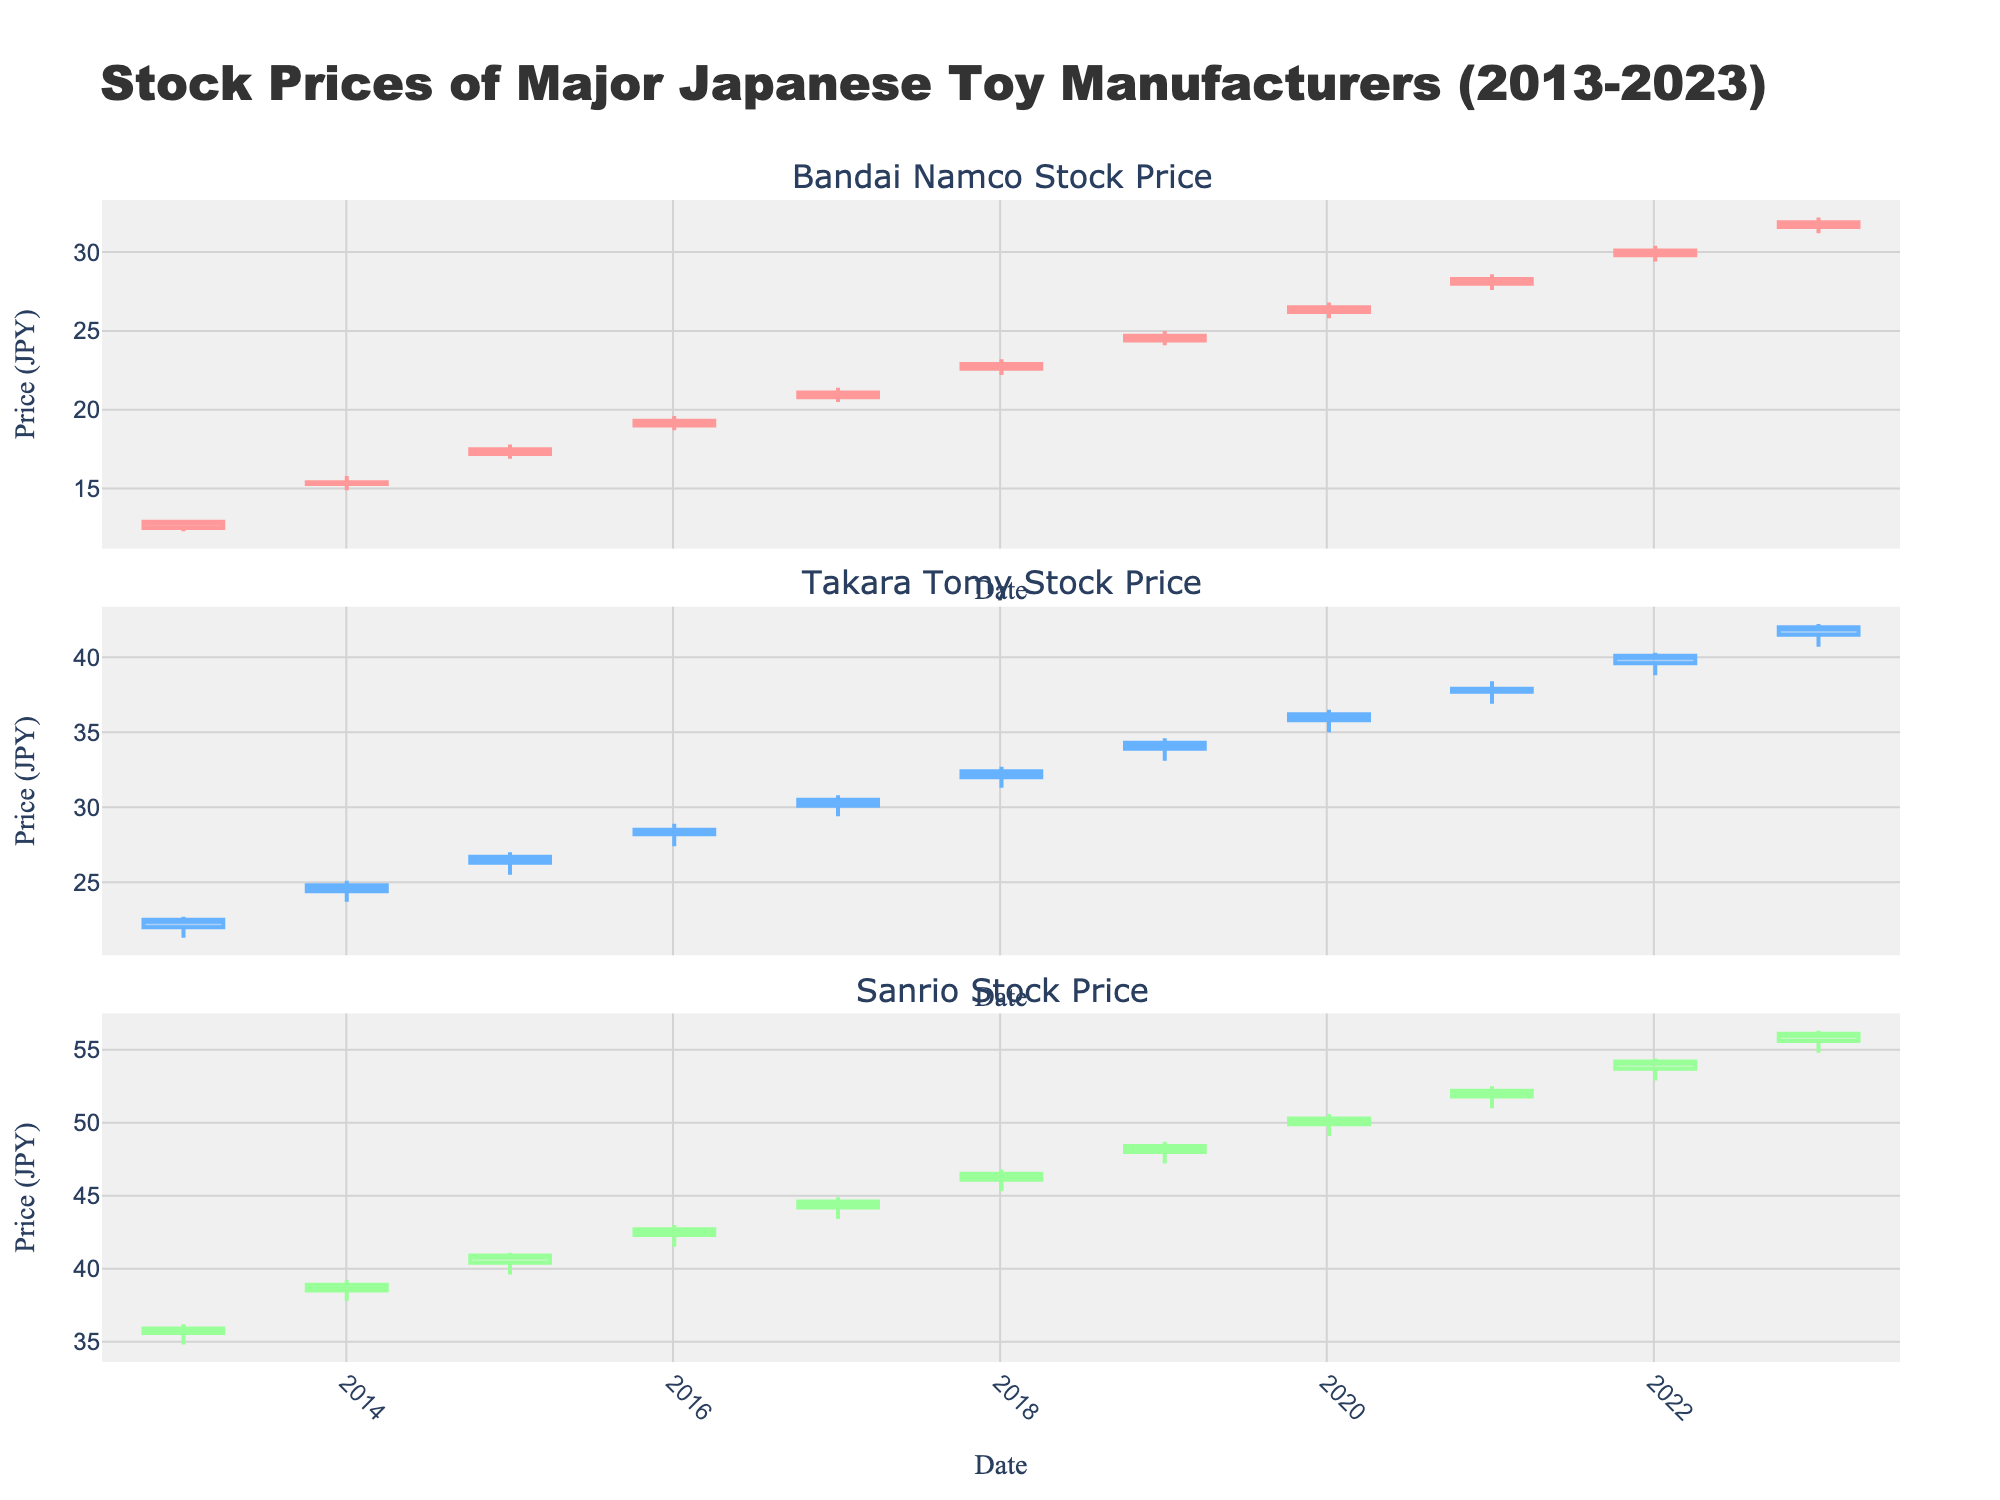Which company shows the highest stock price on any given date between 2013 and 2023? From the plot, look at the highest value reached by each company. Sanrio's stock price peaks at 56.30 around 2023.
Answer: Sanrio What is the general trend of Bandai Namco's stock price from 2013 to 2023? Observing the plot for Bandai Namco, the stock price shows a consistent upward trend starting at about 12.50 in 2013 and rising to around 31.90 by 2023.
Answer: Upward trend How does Takara Tomy's stock price change from 2013 to 2014? From the plot, Takara Tomy's stock price increases from 22.50 in 2013 to 24.80 in 2014.
Answer: Increases What was Sanrio's stock price in January 2017? Refer to the candlestick for January 2017 and observe the closing price. It's around 44.60.
Answer: 44.60 Comparing the trading volumes in 2023, which company had the highest volume? Check the trading volumes for 2023 for all companies. Sanrio has a trading volume of 800,000.
Answer: Sanrio Which company had the highest increase in opening price from 2013 to 2023? Calculate the difference in opening prices from 2013 to 2023 for each company. Bandai Namco's increase is from 12.50 to 31.60 (19.10), Takara Tomy from 22.00 to 41.50 (19.50), and Sanrio from 35.60 to 55.60 (20.00). Sanrio has the highest increase of 20.00.
Answer: Sanrio What was Sanrio's trading volume trend from 2013 to 2023? Observing the trading volume for Sanrio over the years, it shows a steady increase from 600,000 in 2013 to 800,000 in 2023.
Answer: Increasing On which year did Takara Tomy first surpass a closing price of 30? Refer to Takara Tomy's closing prices over the years. The stock price first closes above 30 in 2017 at 30.50.
Answer: 2017 